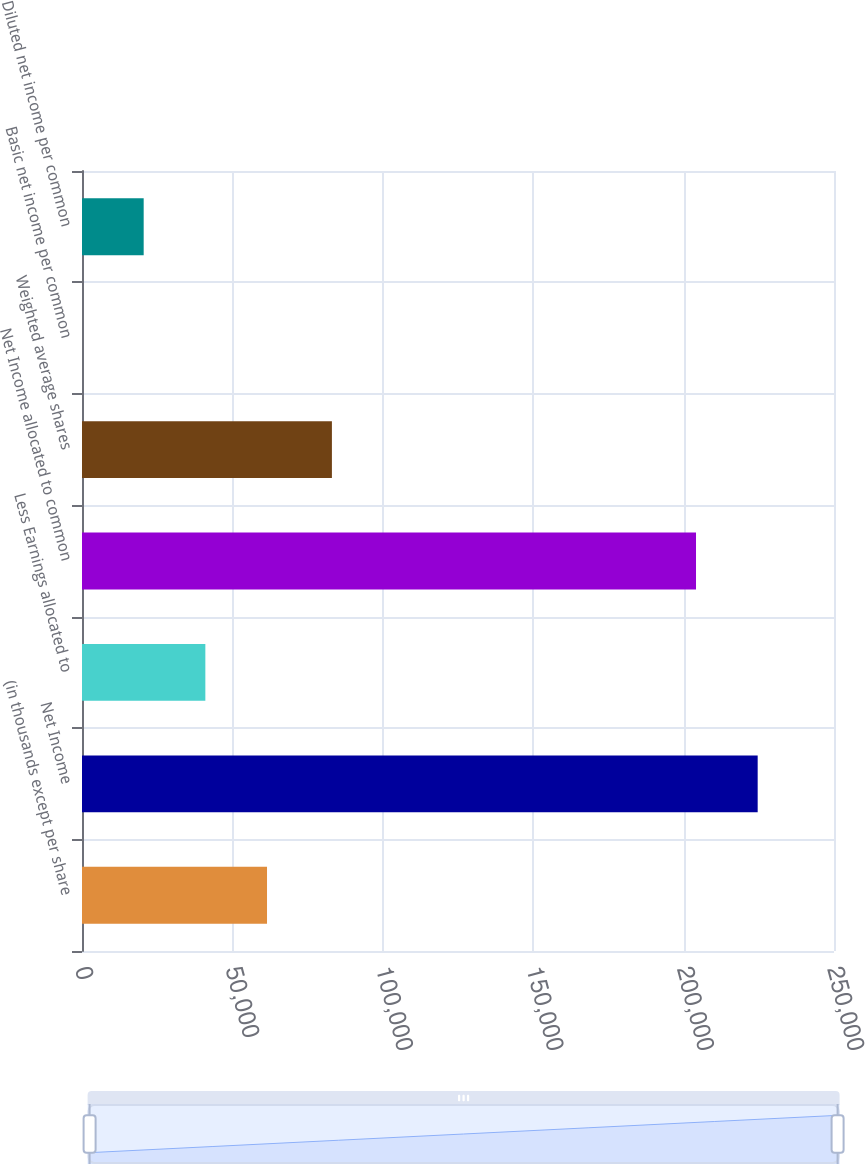<chart> <loc_0><loc_0><loc_500><loc_500><bar_chart><fcel>(in thousands except per share<fcel>Net Income<fcel>Less Earnings allocated to<fcel>Net Income allocated to common<fcel>Weighted average shares<fcel>Basic net income per common<fcel>Diluted net income per common<nl><fcel>61508.6<fcel>224627<fcel>41006.6<fcel>204125<fcel>83081<fcel>2.46<fcel>20504.5<nl></chart> 